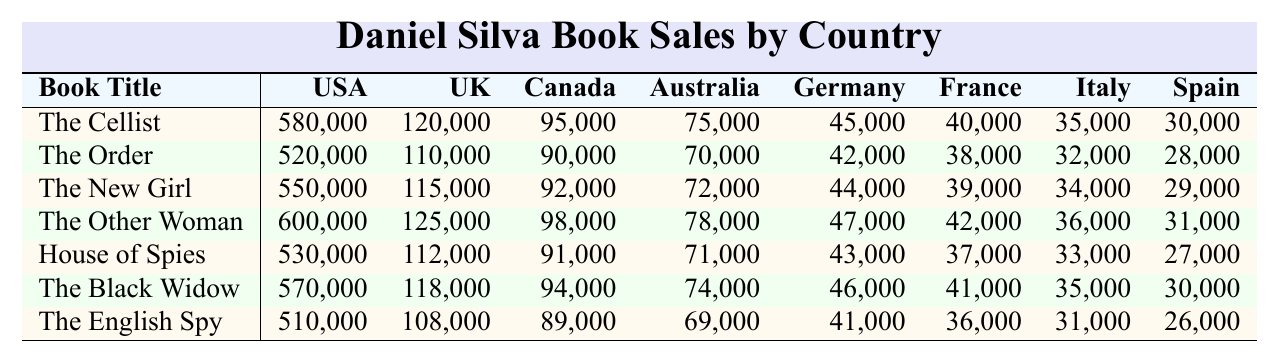What are the sales figures for "The Cellist" in the USA? The sales figures for "The Cellist" in the USA are directly mentioned in the table, which shows 580,000 copies sold.
Answer: 580,000 Which book had the highest sales in the UK? By reviewing the sales figures in the UK column, "The Other Woman" sold 125,000 copies, which is greater than the sales of any other book in the same column.
Answer: The Other Woman What is the total number of sales for "The Black Widow" across all listed countries? The sales figures for "The Black Widow" are: USA: 570,000, UK: 118,000, Canada: 94,000, Australia: 74,000, Germany: 46,000, France: 41,000, Italy: 35,000, Spain: 30,000. Adding these gives: 570,000 + 118,000 + 94,000 + 74,000 + 46,000 + 41,000 + 35,000 + 30,000 = 1,008,000.
Answer: 1,008,000 Which book sold the least in Italy? To determine the book sales in Italy, we can look at the Italy column. The sales figures show that "The English Spy" sold 31,000 copies, which is less than the sales of the other books.
Answer: The English Spy What is the average sales figure for "The Order" across all countries? The sales figures for "The Order" are: USA: 520,000, UK: 110,000, Canada: 90,000, Australia: 70,000, Germany: 42,000, France: 38,000, Italy: 32,000, Spain: 28,000. Summing these gives: 520,000 + 110,000 + 90,000 + 70,000 + 42,000 + 38,000 + 32,000 + 28,000 = 900,000. Dividing by the number of countries (8) gives an average of 900,000 / 8 = 112,500.
Answer: 112,500 Did "House of Spies" sell more copies in Canada than "The Black Widow"? The sales for "House of Spies" in Canada are 91,000, while for "The Black Widow" they are 94,000. Since 91,000 is less than 94,000, "House of Spies" did not sell more.
Answer: No What percentage of the total sales in the USA did "The Other Woman" account for? The sales figures in the USA are: 580,000 for "The Cellist", 520,000 for "The Order", 550,000 for "The New Girl", 600,000 for "The Other Woman", 530,000 for "House of Spies", 570,000 for "The Black Widow", and 510,000 for "The English Spy." The total sales for USA are: 580,000 + 520,000 + 550,000 + 600,000 + 530,000 + 570,000 + 510,000 = 3,860,000. "The Other Woman" sold 600,000, so the percentage is (600,000 / 3,860,000) * 100 ≈ 15.5%.
Answer: 15.5% What is the difference in sales between "The New Girl" and "The Cellist" in Australia? The sales figures show that "The New Girl" sold 72,000 copies in Australia while "The Cellist" sold 75,000 copies. The difference is 75,000 - 72,000 = 3,000.
Answer: 3,000 What is the median sales figure for the book "The English Spy" across the countries? The sales figures for "The English Spy" are: USA (510,000), UK (108,000), Canada (89,000), Australia (69,000), Germany (41,000), France (36,000), Italy (31,000), and Spain (26,000). Arranging these in order gives: 26,000, 31,000, 36,000, 41,000, 69,000, 89,000, 108,000, 510,000. Since there are 8 data points, the median will be the average of the 4th and 5th values: (41,000 + 69,000) / 2 = 55,000.
Answer: 55,000 Which country had the lowest sales for "The Order"? The sales for "The Order" across the countries are: USA: 520,000, UK: 110,000, Canada: 90,000, Australia: 70,000, Germany: 42,000, France: 38,000, Italy: 32,000, Spain: 28,000. The lowest sales figure is in Spain at 28,000.
Answer: Spain 